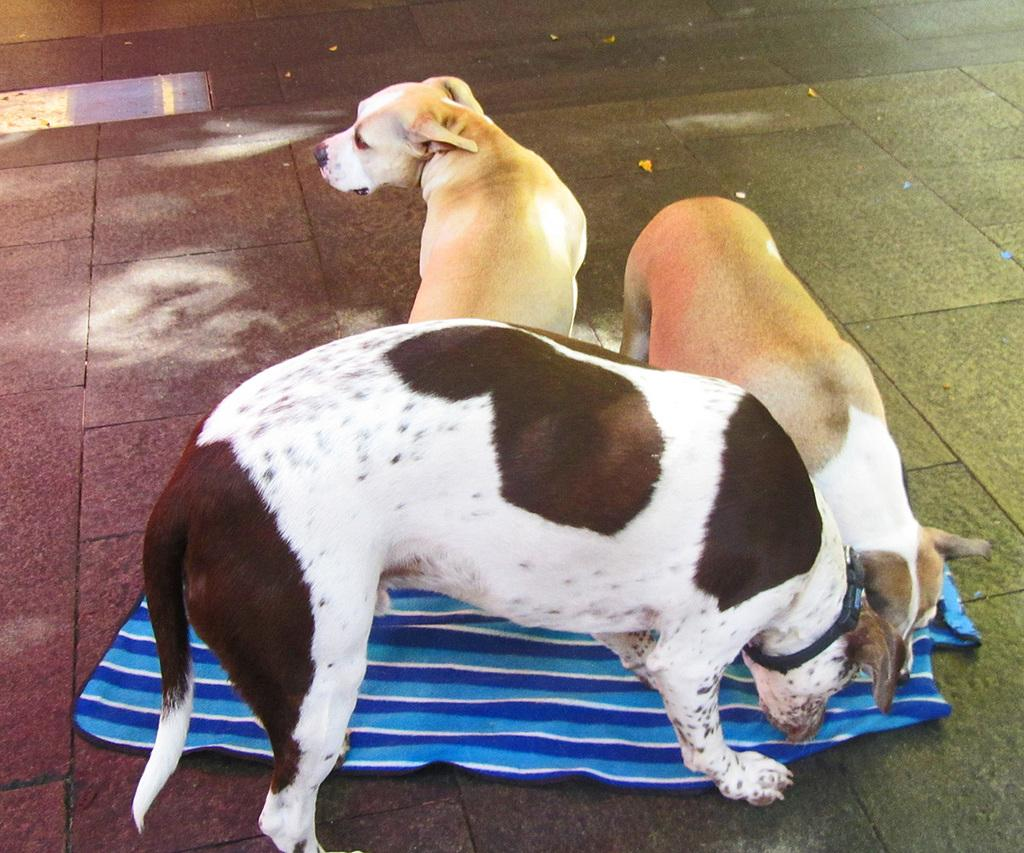How many dogs are present in the image? There are three dogs in the image. What are the dogs doing in the image? The dogs are playing in the image. Can you describe any objects on the floor in the image? There is an object on the floor in the image. How many mice can be seen hiding under the seat in the image? There are no mice or seats present in the image; it features three dogs playing. 